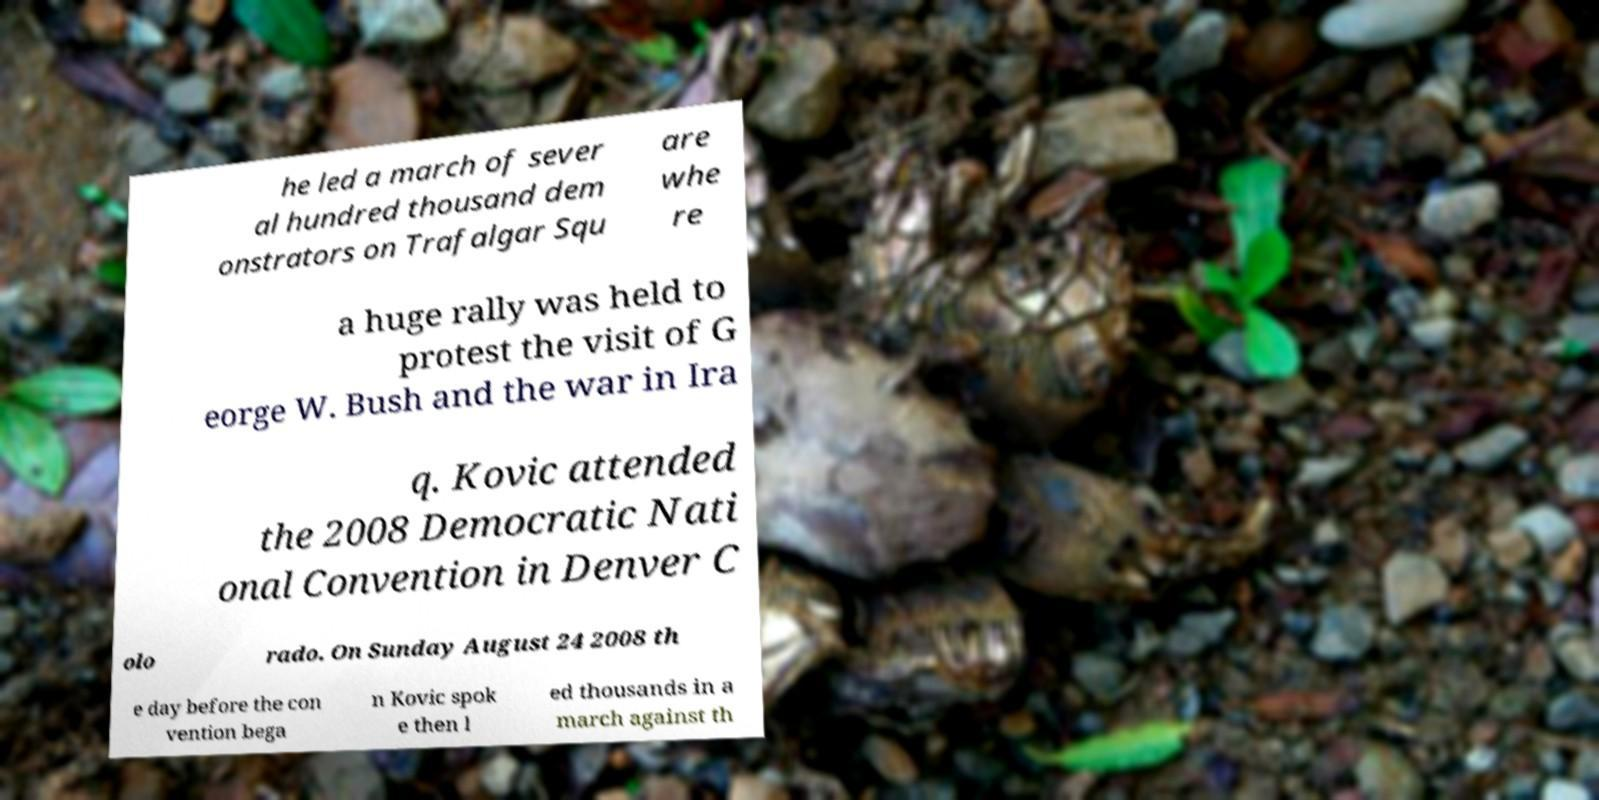Can you accurately transcribe the text from the provided image for me? he led a march of sever al hundred thousand dem onstrators on Trafalgar Squ are whe re a huge rally was held to protest the visit of G eorge W. Bush and the war in Ira q. Kovic attended the 2008 Democratic Nati onal Convention in Denver C olo rado. On Sunday August 24 2008 th e day before the con vention bega n Kovic spok e then l ed thousands in a march against th 